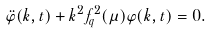Convert formula to latex. <formula><loc_0><loc_0><loc_500><loc_500>\ddot { \varphi } ( k , t ) + k ^ { 2 } f _ { q } ^ { 2 } ( \mu ) \varphi ( k , t ) = 0 .</formula> 